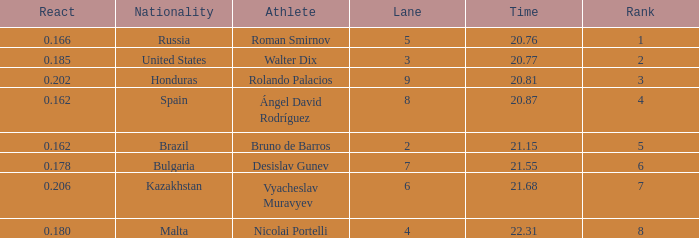What's Bulgaria's lane with a time more than 21.55? None. 